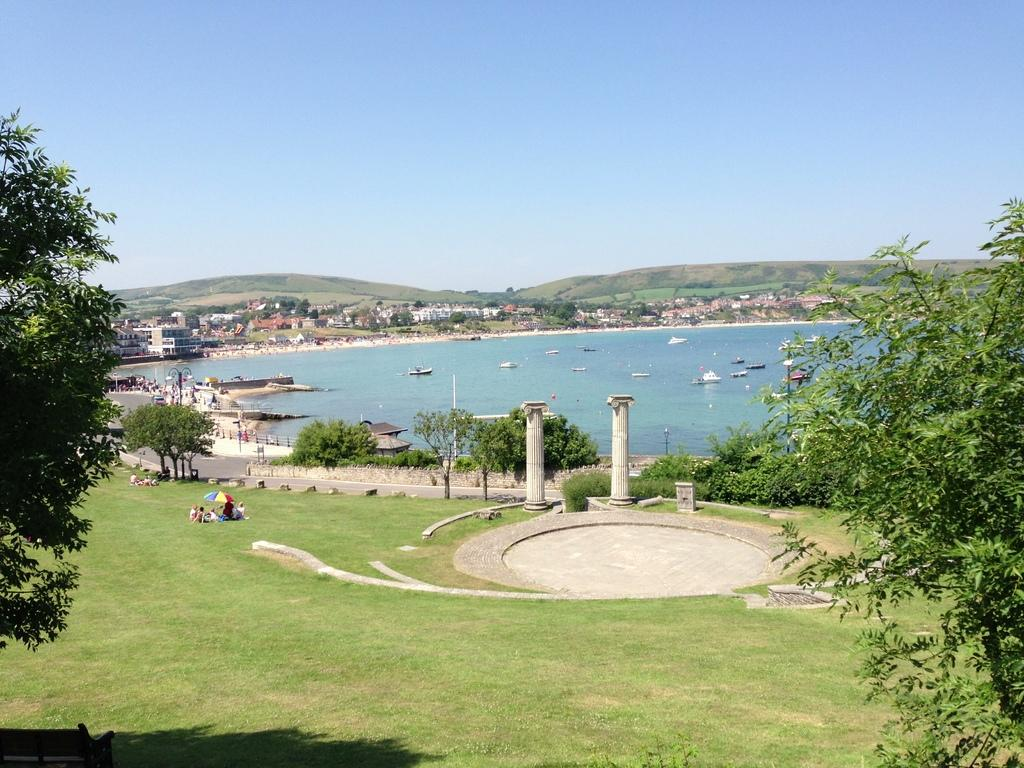What is the surface that the persons are standing on in the image? The ground is covered with grass, and the persons are standing on it. What type of vegetation can be seen in the image? There are trees and plants visible in the image. What objects are present in the image that might be used for sitting or lying down? There are pillows in the image. What type of transportation can be seen in the image? There are boats in the image. What type of structures can be seen in the image? There are houses in the image. What is the liquid visible in the image? There is water visible in the image. What type of pathway can be seen in the image? There is a road in the image. What is visible in the background of the image? The sky is visible in the background of the image. What type of drug is being sold in the image? There is no indication of any drug being sold or present in the image. What is the zinc content of the water visible in the image? There is no information provided about the zinc content of the water in the image. What type of experience can be gained from the image? The image is a static representation and does not offer any direct experience. 